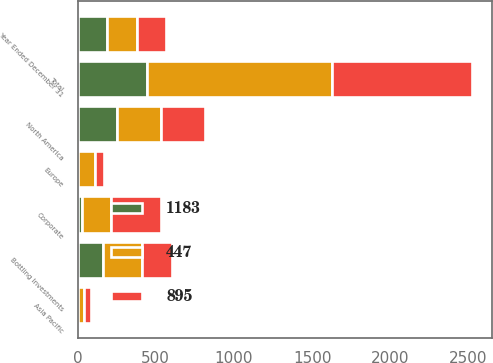Convert chart to OTSL. <chart><loc_0><loc_0><loc_500><loc_500><stacked_bar_chart><ecel><fcel>Year Ended December 31<fcel>Europe<fcel>North America<fcel>Asia Pacific<fcel>Bottling Investments<fcel>Corporate<fcel>Total<nl><fcel>447<fcel>189.5<fcel>111<fcel>281<fcel>38<fcel>247<fcel>185<fcel>1183<nl><fcel>895<fcel>189.5<fcel>57<fcel>277<fcel>47<fcel>194<fcel>318<fcel>895<nl><fcel>1183<fcel>189.5<fcel>3<fcel>255<fcel>1<fcel>164<fcel>30<fcel>447<nl></chart> 